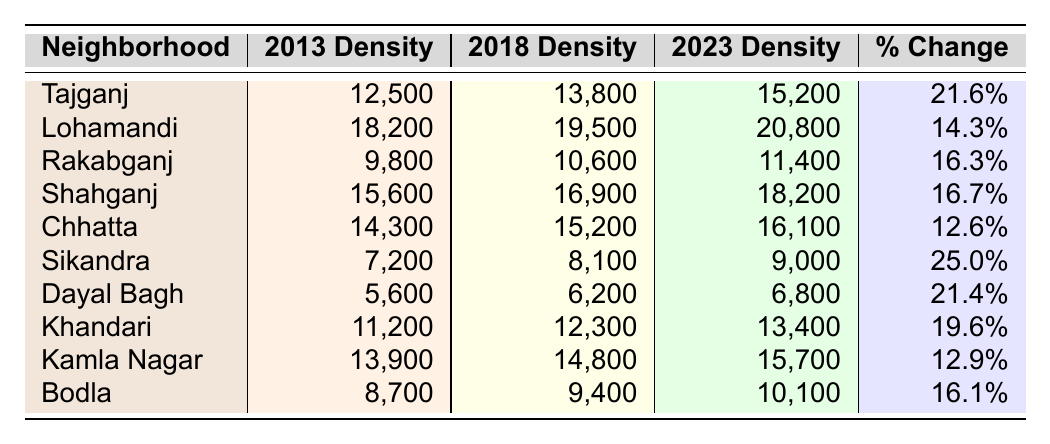What was the population density of Tajganj in 2023? The table shows that the population density of Tajganj in 2023 is listed as 15,200 per square kilometer.
Answer: 15,200 Which neighborhood had the highest population density in 2018? By comparing the 2018 density values, Lohamandi has the highest density of 19,500 per square kilometer.
Answer: Lohamandi What is the percentage change in population density for Sikandra from 2013 to 2023? The percentage change for Sikandra is provided in the table as 25.0%.
Answer: 25.0% What is the average population density in 2023 for all neighborhoods listed? Adding the 2023 densities: (15,200 + 20,800 + 11,400 + 18,200 + 16,100 + 9,000 + 6,800 + 13,400 + 15,700 + 10,100) = 126,700. There are 10 neighborhoods, so the average is 126,700/10 = 12,670.
Answer: 12,670 Did any neighborhood have a percentage change of over 20% from 2013 to 2023? Reviewing the percentage changes, both Tajganj (21.6%) and Sikandra (25.0%) exceeded 20%.
Answer: Yes Which neighborhood experienced the least percentage change over the decade? By examining the percentage changes, Chhatta had the least at 12.6%.
Answer: Chhatta Calculate the difference in population density between 2023 and 2013 for Lohamandi. The density for Lohamandi in 2023 is 20,800 and in 2013 it was 18,200. The difference is 20,800 - 18,200 = 2,600.
Answer: 2,600 Is the population density in Bodla in 2013 greater than that in Dayal Bagh? The densities in 2013 show Bodla at 8,700 and Dayal Bagh at 5,600; thus, Bodla is greater.
Answer: Yes Which two neighborhoods had the same growth trend in density over the decade? Examining the percentage changes, Rakabganj (16.3%) and Shahganj (16.7%) show similar trends of growth within a close range.
Answer: Rakabganj and Shahganj What is the total population density of all neighborhoods in 2018? Summing the 2018 densities: (13,800 + 19,500 + 10,600 + 16,900 + 15,200 + 8,100 + 6,200 + 12,300 + 14,800 + 9,400) = 116,600.
Answer: 116,600 